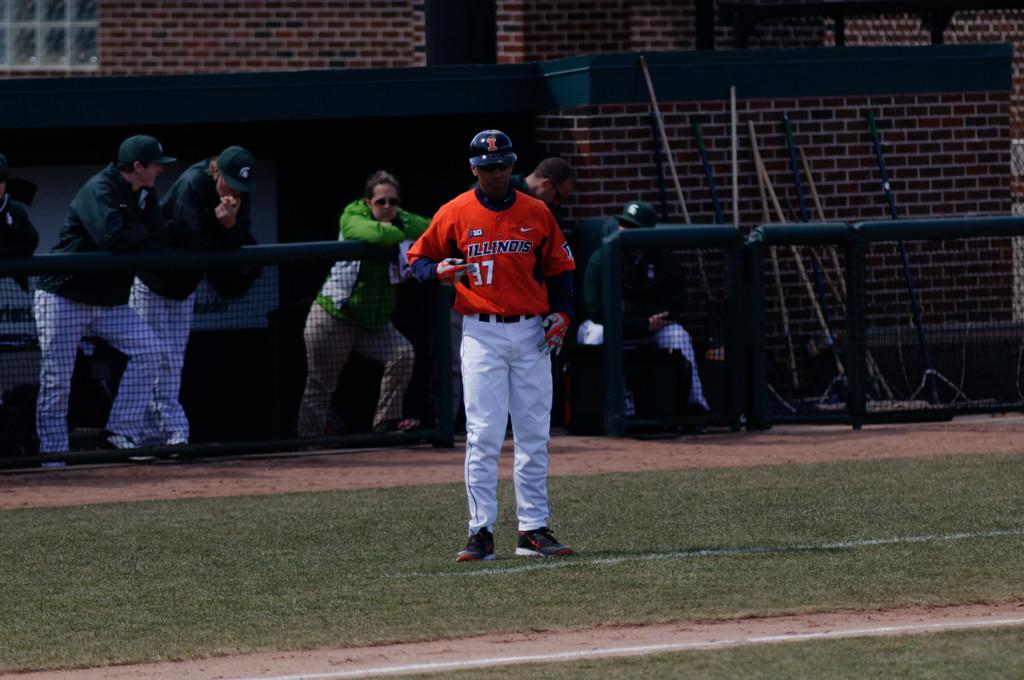<image>
Write a terse but informative summary of the picture. A baseball player has a uniform with the number 37 on it. 